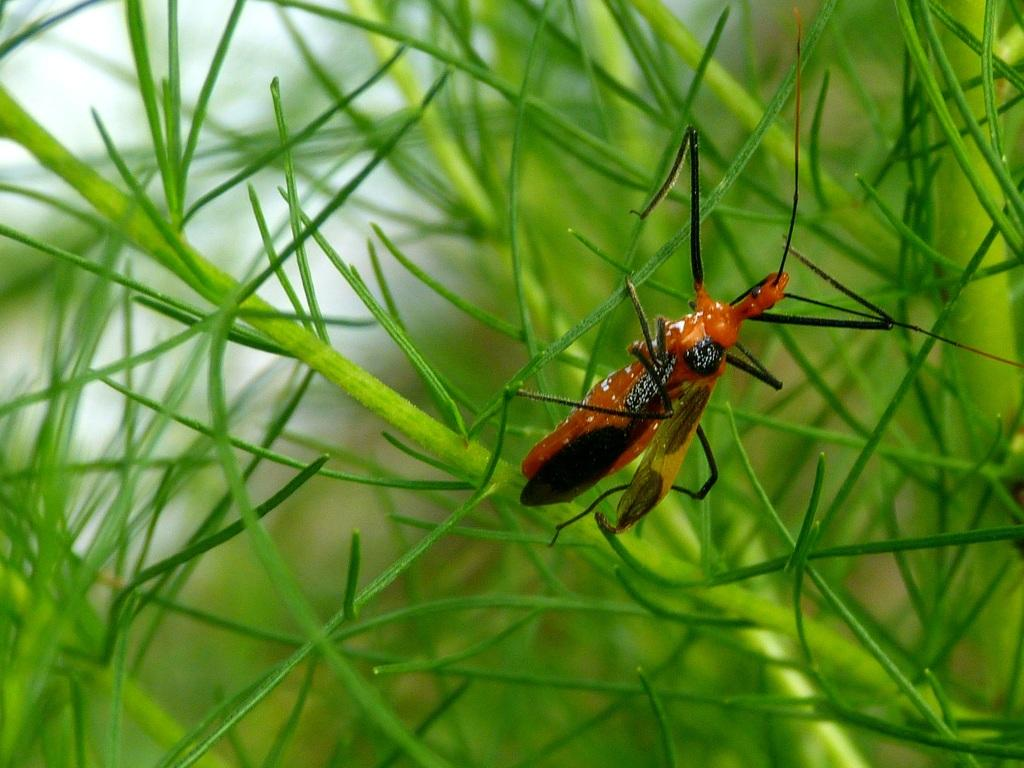What type of living organism can be seen in the image? There is an insect in the image. What can be seen in the background of the image? There are plants in the background of the image. What type of window can be seen in the image? There is no window present in the image; it only features an insect and plants in the background. 